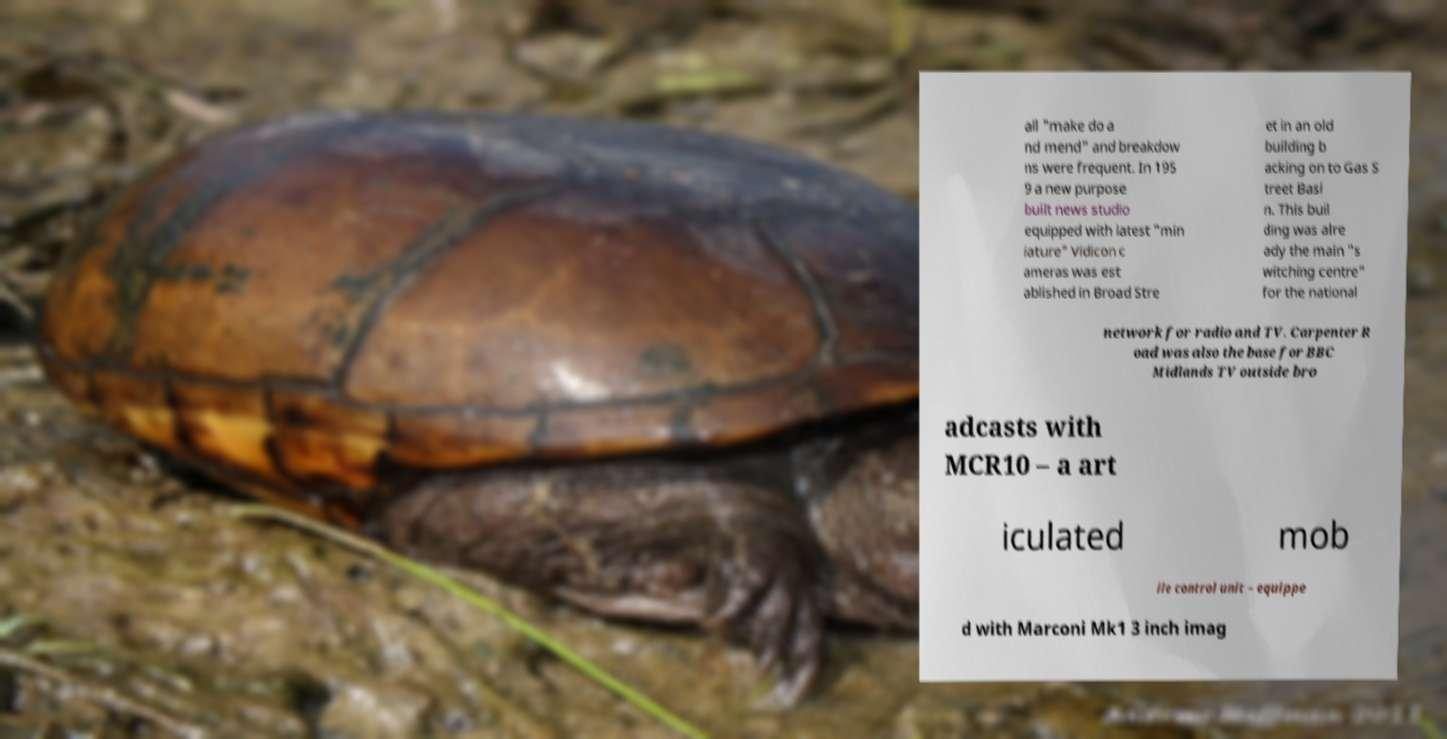I need the written content from this picture converted into text. Can you do that? all "make do a nd mend" and breakdow ns were frequent. In 195 9 a new purpose built news studio equipped with latest "min iature" Vidicon c ameras was est ablished in Broad Stre et in an old building b acking on to Gas S treet Basi n. This buil ding was alre ady the main "s witching centre" for the national network for radio and TV. Carpenter R oad was also the base for BBC Midlands TV outside bro adcasts with MCR10 – a art iculated mob ile control unit – equippe d with Marconi Mk1 3 inch imag 